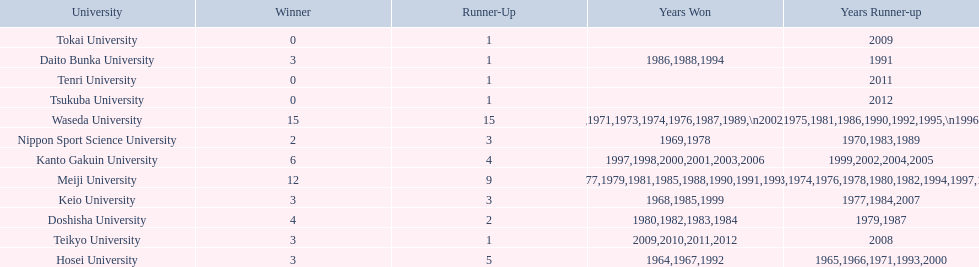What are all of the universities? Waseda University, Meiji University, Kanto Gakuin University, Doshisha University, Hosei University, Keio University, Daito Bunka University, Nippon Sport Science University, Teikyo University, Tokai University, Tenri University, Tsukuba University. And their scores? 15, 12, 6, 4, 3, 3, 3, 2, 3, 0, 0, 0. Which university scored won the most? Waseda University. 